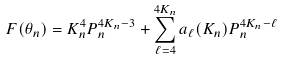Convert formula to latex. <formula><loc_0><loc_0><loc_500><loc_500>F ( \theta _ { n } ) = K _ { n } ^ { 4 } P _ { n } ^ { 4 K _ { n } - 3 } + \sum _ { \ell = 4 } ^ { 4 K _ { n } } a _ { \ell } ( K _ { n } ) P _ { n } ^ { 4 K _ { n } - \ell }</formula> 